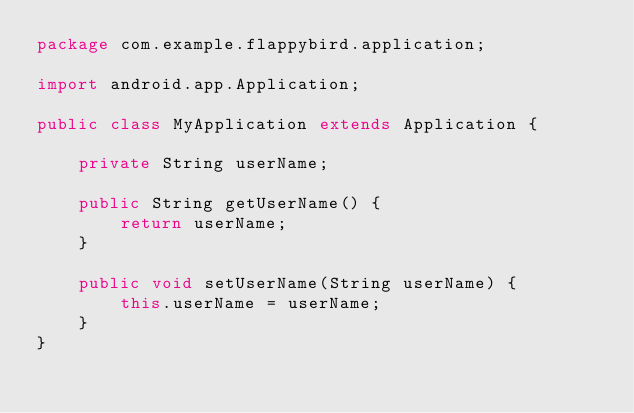Convert code to text. <code><loc_0><loc_0><loc_500><loc_500><_Java_>package com.example.flappybird.application;

import android.app.Application;

public class MyApplication extends Application {

    private String userName;

    public String getUserName() {
        return userName;
    }

    public void setUserName(String userName) {
        this.userName = userName;
    }
}</code> 